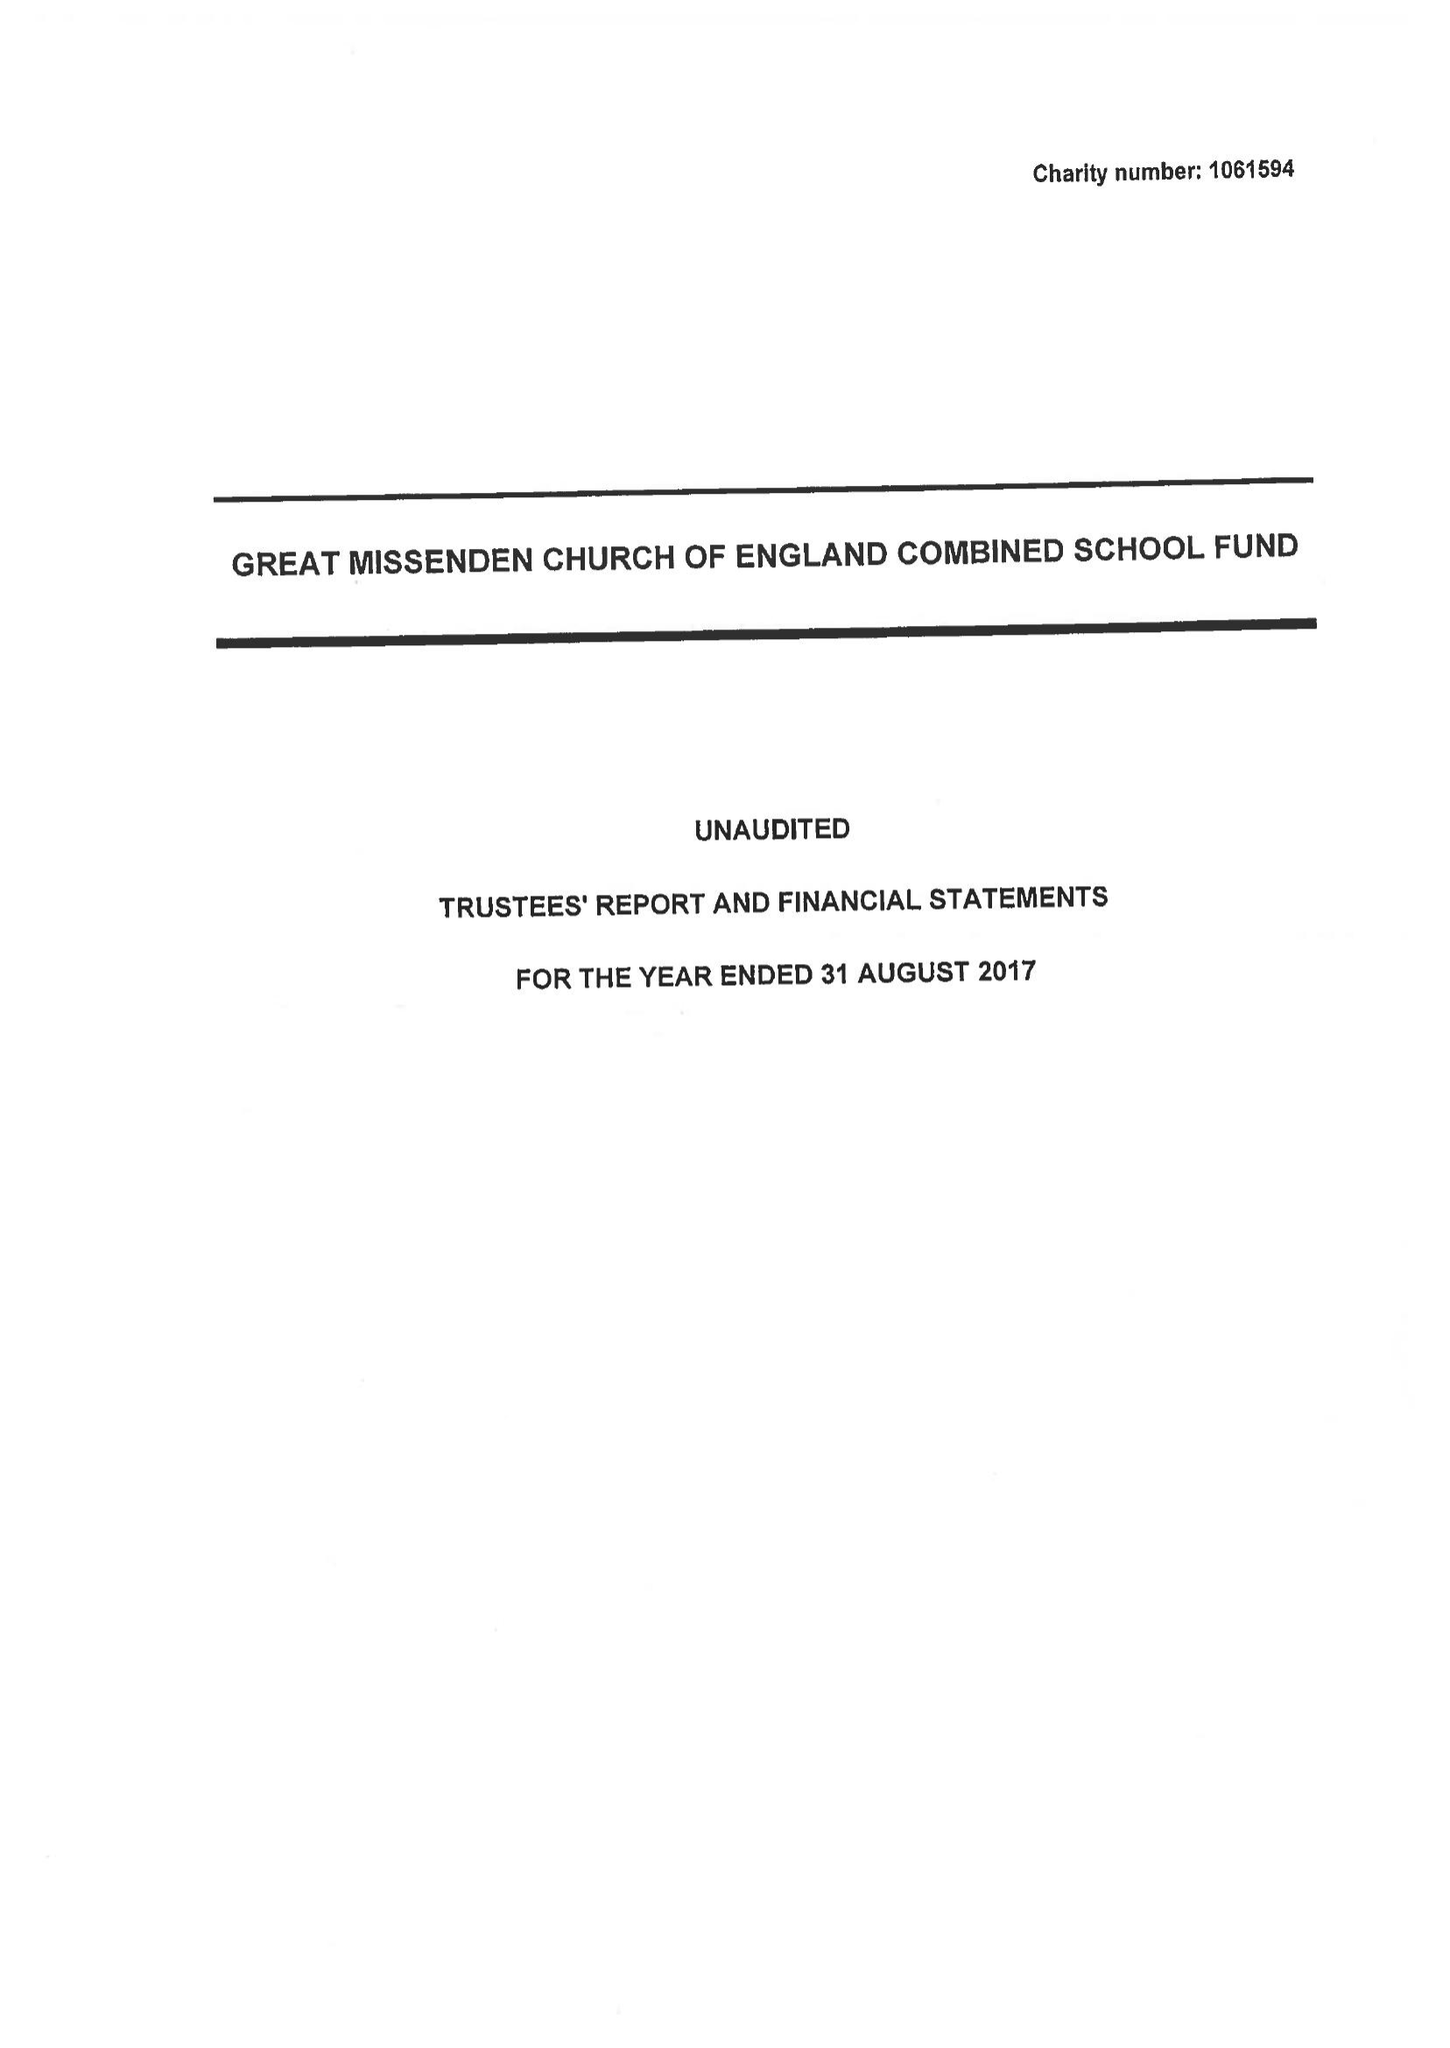What is the value for the address__postcode?
Answer the question using a single word or phrase. HP16 0AZ 